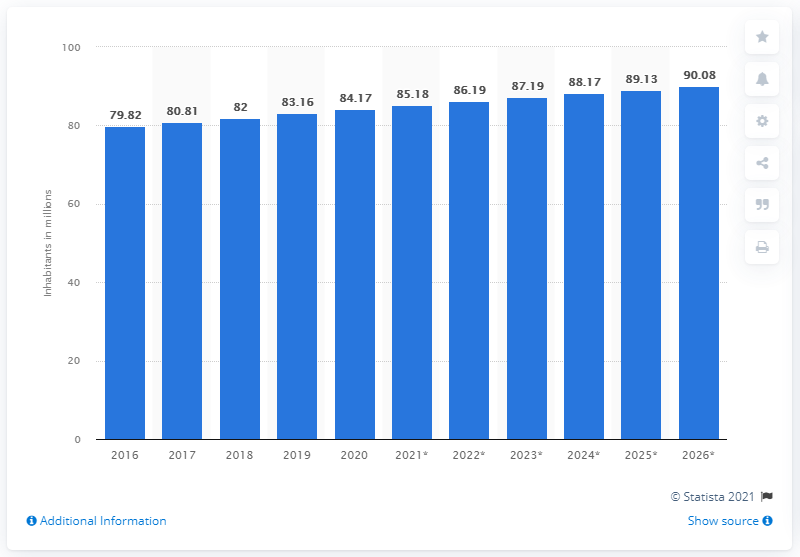Outline some significant characteristics in this image. In 2020, Turkey's population reached 84.17 million people. In 2020, the population of Turkey was 84.17 million. 